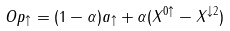<formula> <loc_0><loc_0><loc_500><loc_500>O p _ { \uparrow } = ( 1 - \alpha ) a _ { \uparrow } + \alpha ( X ^ { 0 \uparrow } - X ^ { \downarrow 2 } )</formula> 